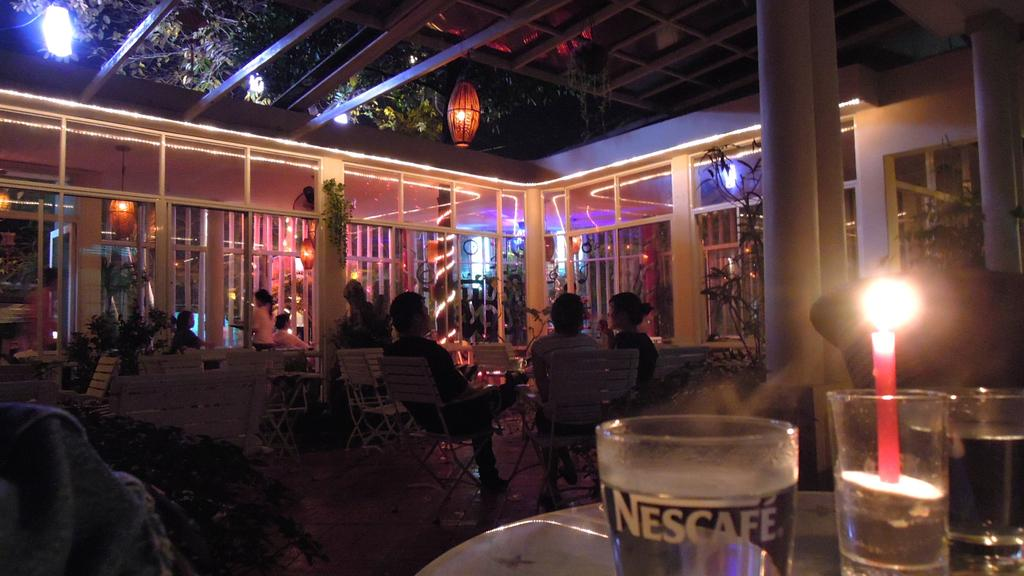<image>
Summarize the visual content of the image. a shot of a crowded bar or cafe with a glass reading Nescafe near the front. 